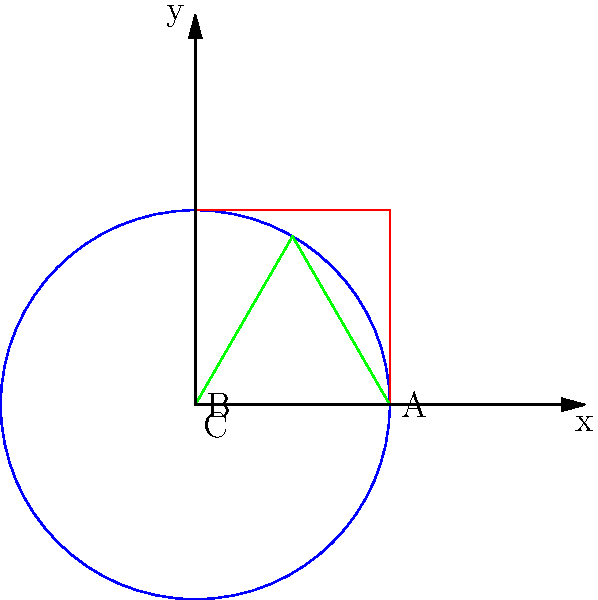In the context of Tom Waits' eclectic discography, consider three hypothetical album shapes: circular (A), square (B), and triangular (C). Which shape would result in a path traced by the record needle that is homeomorphic to a circle? To determine which album shape results in a path homeomorphic to a circle, we need to consider the properties of each shape:

1. Circular album (A):
   - The needle traces a circular path from the outer edge to the center.
   - This path is continuous and closed.
   - It can be continuously deformed into a circle without breaking or gluing.

2. Square album (B):
   - The needle would trace a spiral-like path from the outer edge to the center.
   - While continuous, this path is not closed as it ends at the center.
   - It cannot be deformed into a circle without additional operations.

3. Triangular album (C):
   - Similar to the square, the needle would trace a spiral-like path.
   - This path is also continuous but not closed.
   - It cannot be deformed into a circle without additional operations.

A homeomorphism is a continuous bijection with a continuous inverse. For a path to be homeomorphic to a circle, it must be:
1. Continuous
2. Closed (no endpoints)
3. Non-self-intersecting

Only the circular album (A) satisfies all these conditions. The paths on the square and triangular albums, while continuous, are not closed and thus not homeomorphic to a circle.
Answer: A (circular album) 